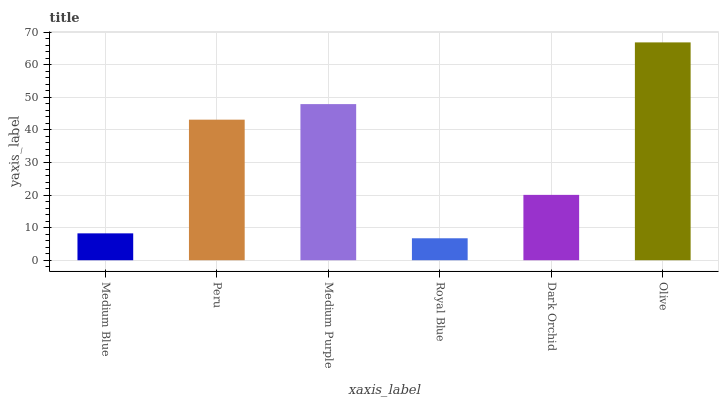Is Royal Blue the minimum?
Answer yes or no. Yes. Is Olive the maximum?
Answer yes or no. Yes. Is Peru the minimum?
Answer yes or no. No. Is Peru the maximum?
Answer yes or no. No. Is Peru greater than Medium Blue?
Answer yes or no. Yes. Is Medium Blue less than Peru?
Answer yes or no. Yes. Is Medium Blue greater than Peru?
Answer yes or no. No. Is Peru less than Medium Blue?
Answer yes or no. No. Is Peru the high median?
Answer yes or no. Yes. Is Dark Orchid the low median?
Answer yes or no. Yes. Is Dark Orchid the high median?
Answer yes or no. No. Is Peru the low median?
Answer yes or no. No. 